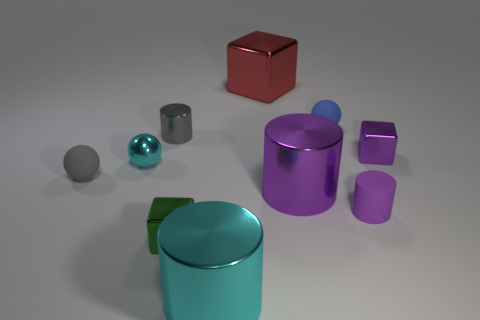What is the color of the small cube that is behind the purple metallic cylinder?
Your response must be concise. Purple. Is the number of things behind the large cube less than the number of objects that are on the right side of the small gray matte object?
Give a very brief answer. Yes. How many other things are there of the same material as the tiny green object?
Provide a succinct answer. 6. Is the material of the red thing the same as the small purple cylinder?
Offer a terse response. No. What number of other things are there of the same size as the cyan metallic cylinder?
Ensure brevity in your answer.  2. There is a matte sphere that is on the left side of the metallic cylinder to the left of the small green shiny object; what size is it?
Offer a terse response. Small. There is a big cylinder that is on the left side of the large shiny cylinder that is behind the shiny thing in front of the green thing; what color is it?
Give a very brief answer. Cyan. What size is the shiny object that is both behind the tiny cyan metallic sphere and left of the green metal cube?
Offer a terse response. Small. What number of other objects are the same shape as the gray rubber thing?
Your answer should be compact. 2. What number of spheres are tiny purple objects or purple rubber things?
Provide a short and direct response. 0. 